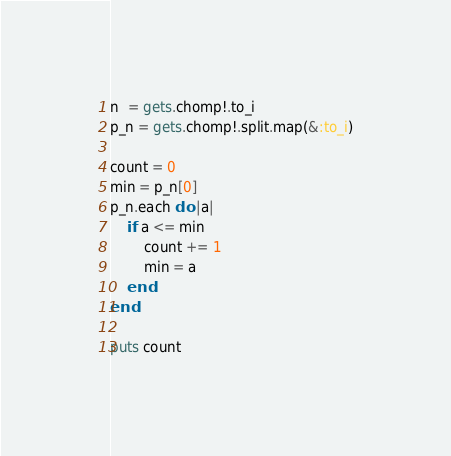Convert code to text. <code><loc_0><loc_0><loc_500><loc_500><_Ruby_>n  = gets.chomp!.to_i
p_n = gets.chomp!.split.map(&:to_i)

count = 0
min = p_n[0]
p_n.each do |a|
    if a <= min
        count += 1
        min = a
    end
end

puts count
</code> 